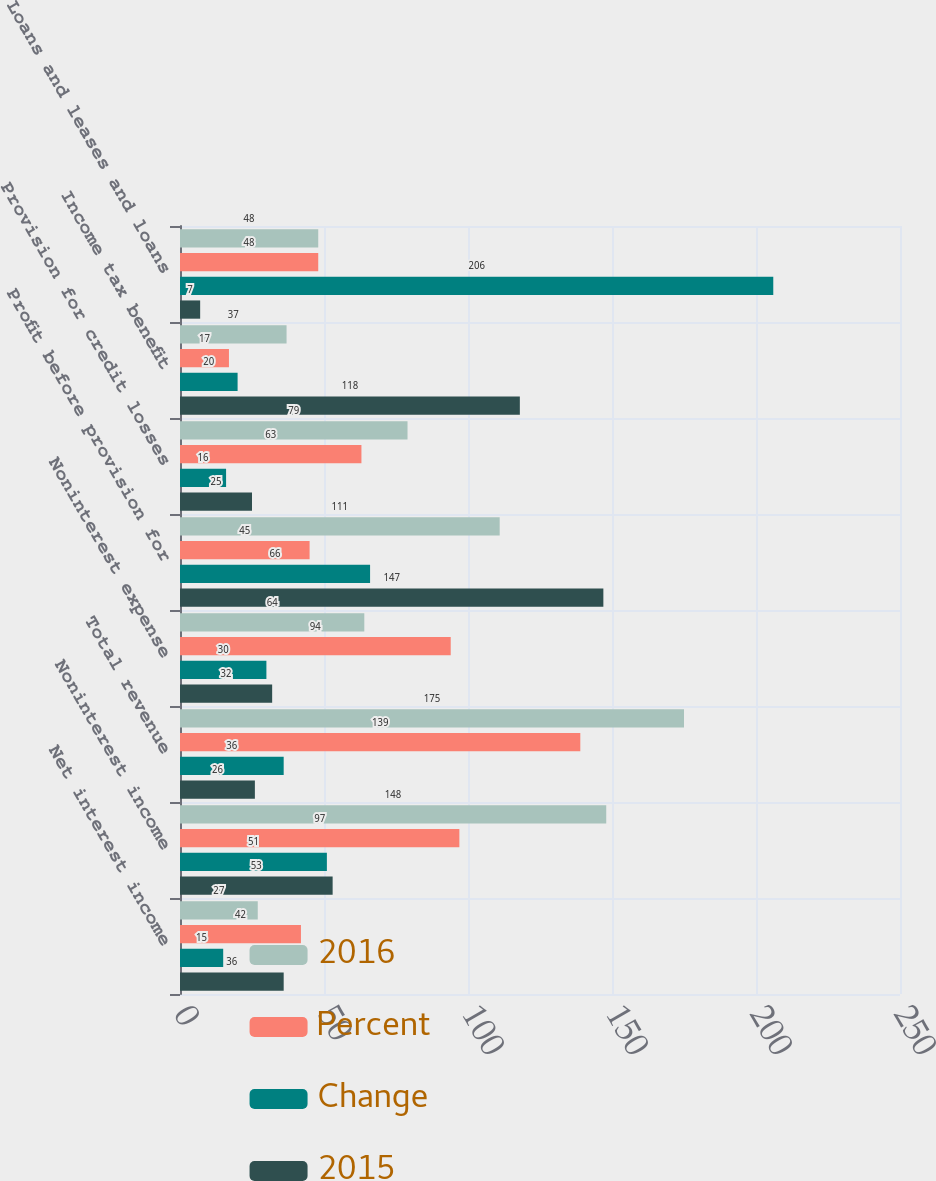Convert chart to OTSL. <chart><loc_0><loc_0><loc_500><loc_500><stacked_bar_chart><ecel><fcel>Net interest income<fcel>Noninterest income<fcel>Total revenue<fcel>Noninterest expense<fcel>Profit before provision for<fcel>Provision for credit losses<fcel>Income tax benefit<fcel>Loans and leases and loans<nl><fcel>2016<fcel>27<fcel>148<fcel>175<fcel>64<fcel>111<fcel>79<fcel>37<fcel>48<nl><fcel>Percent<fcel>42<fcel>97<fcel>139<fcel>94<fcel>45<fcel>63<fcel>17<fcel>48<nl><fcel>Change<fcel>15<fcel>51<fcel>36<fcel>30<fcel>66<fcel>16<fcel>20<fcel>206<nl><fcel>2015<fcel>36<fcel>53<fcel>26<fcel>32<fcel>147<fcel>25<fcel>118<fcel>7<nl></chart> 